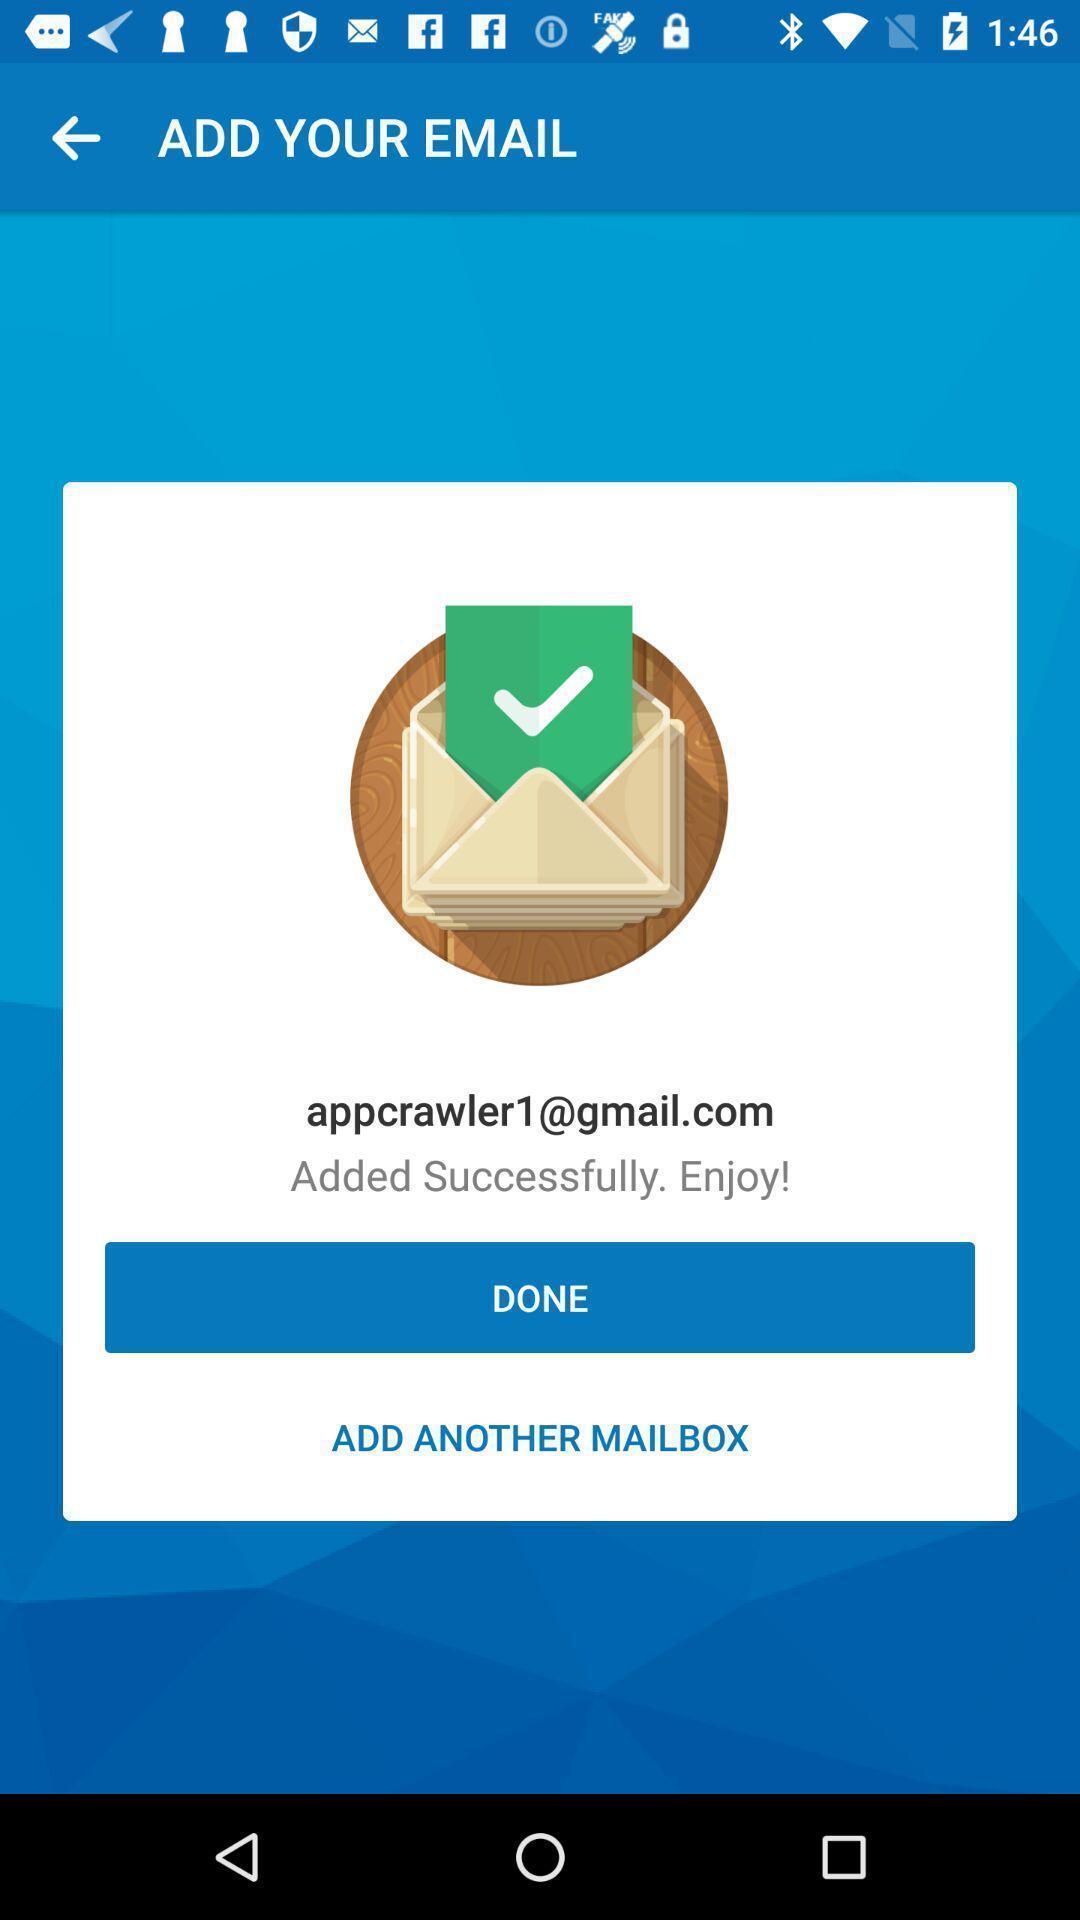Provide a detailed account of this screenshot. Pop-up showing to add another email. 